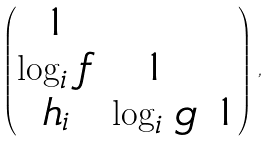Convert formula to latex. <formula><loc_0><loc_0><loc_500><loc_500>\begin{pmatrix} 1 & & \\ \log _ { i } \, f & 1 & \\ h _ { i } & \log _ { i } \, g & 1 \end{pmatrix} \, ,</formula> 